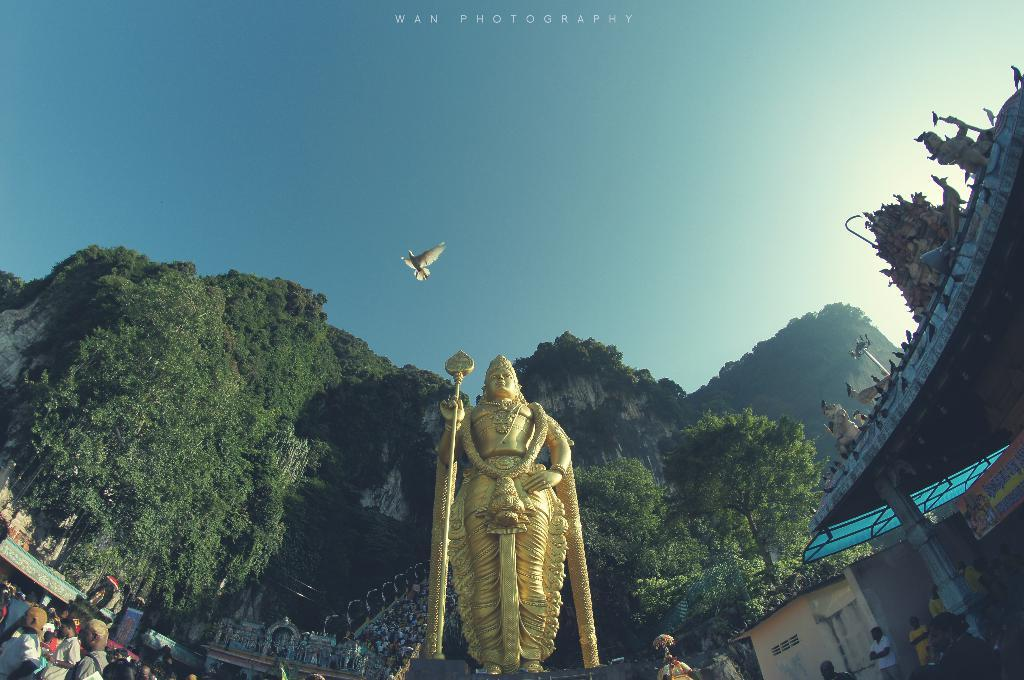What is the main subject in the image? There is a statue in the image. What else can be seen in the background of the image? There are people standing in the background of the image. What type of vegetation is present in the image? There are trees with green leaves in the image. What kind of bird can be seen in the image? There is a bird with white feathers in the image. What is the color of the sky in the image? The sky is blue and white in color. What type of silk material is draped over the dock in the image? There is no dock or silk material present in the image. 